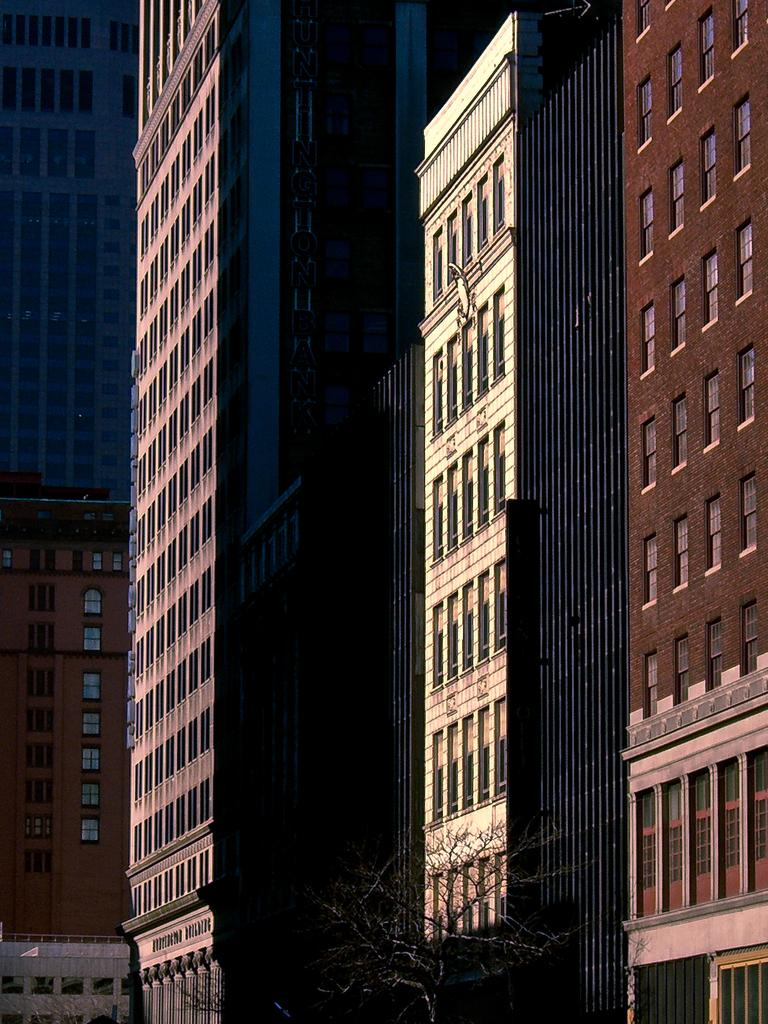What type of structures are visible in the image? There are many tall buildings in the image. Can you describe the color of one of the buildings? One of the buildings is in brown color. What type of vegetation can be seen at the bottom of the image? There is a tree at the bottom of the image. What type of juice is being served to the men in the image? There are no men or juice present in the image; it features tall buildings and a tree. 